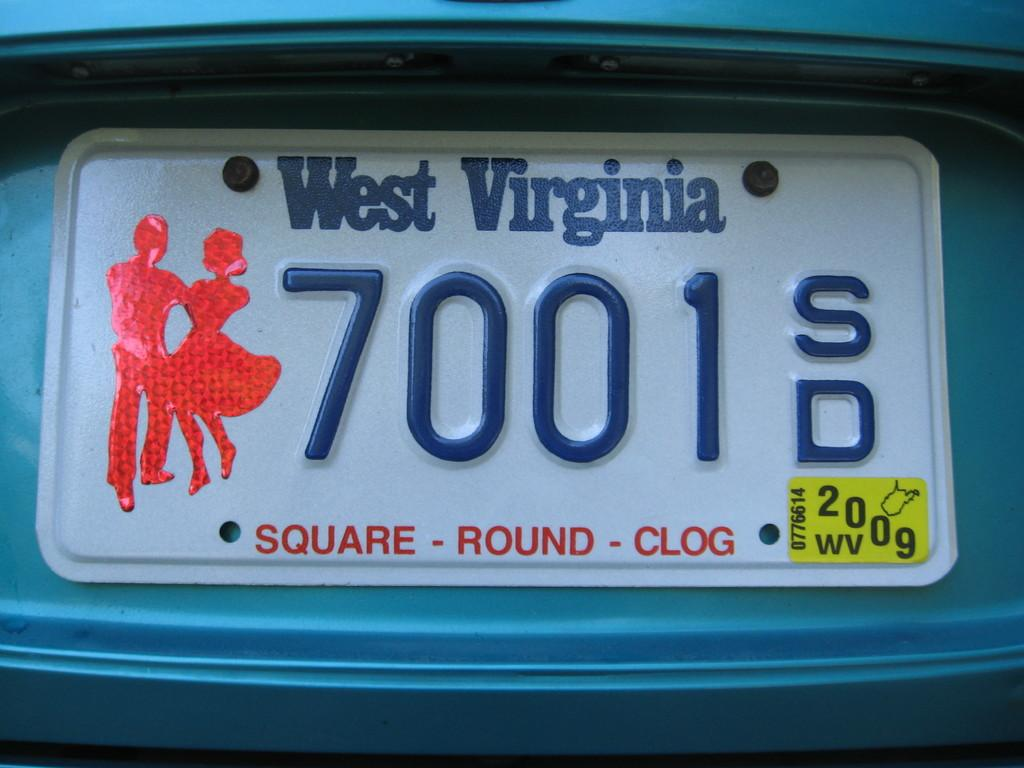<image>
Present a compact description of the photo's key features. A West Virginia license plate says square, round, clog along the bottom. 